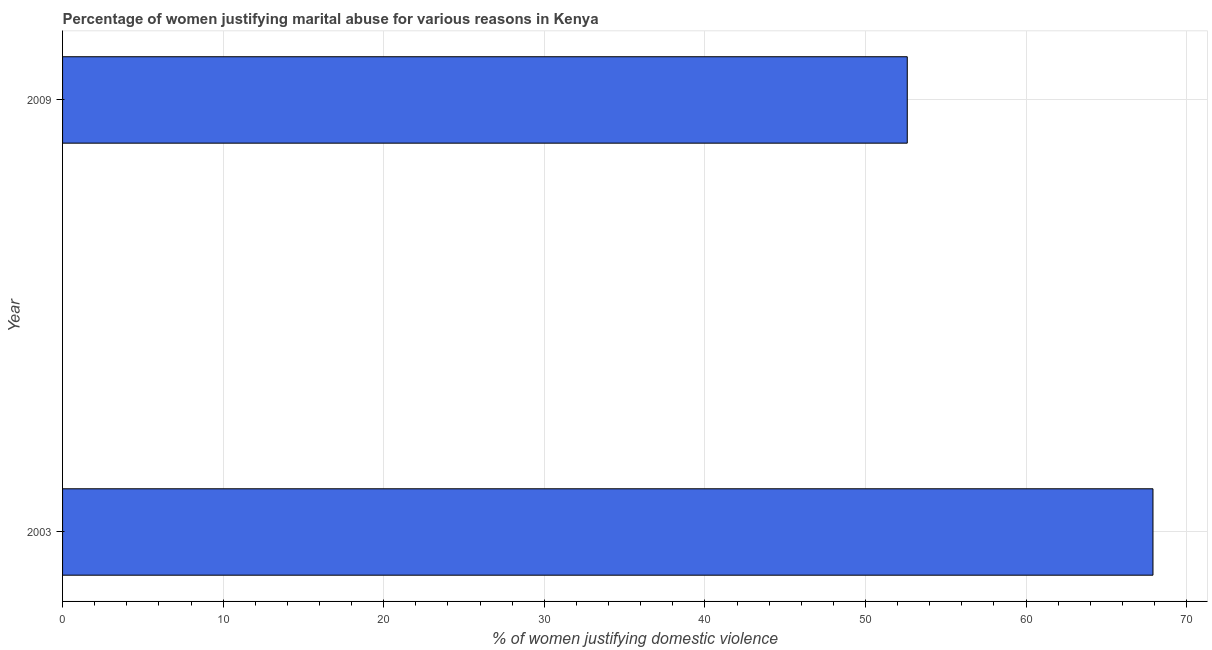Does the graph contain any zero values?
Keep it short and to the point. No. What is the title of the graph?
Give a very brief answer. Percentage of women justifying marital abuse for various reasons in Kenya. What is the label or title of the X-axis?
Give a very brief answer. % of women justifying domestic violence. What is the label or title of the Y-axis?
Provide a succinct answer. Year. What is the percentage of women justifying marital abuse in 2003?
Your response must be concise. 67.9. Across all years, what is the maximum percentage of women justifying marital abuse?
Your response must be concise. 67.9. Across all years, what is the minimum percentage of women justifying marital abuse?
Your answer should be very brief. 52.6. In which year was the percentage of women justifying marital abuse minimum?
Provide a succinct answer. 2009. What is the sum of the percentage of women justifying marital abuse?
Your answer should be compact. 120.5. What is the average percentage of women justifying marital abuse per year?
Provide a succinct answer. 60.25. What is the median percentage of women justifying marital abuse?
Offer a terse response. 60.25. In how many years, is the percentage of women justifying marital abuse greater than 16 %?
Provide a succinct answer. 2. Do a majority of the years between 2003 and 2009 (inclusive) have percentage of women justifying marital abuse greater than 2 %?
Offer a very short reply. Yes. What is the ratio of the percentage of women justifying marital abuse in 2003 to that in 2009?
Your response must be concise. 1.29. In how many years, is the percentage of women justifying marital abuse greater than the average percentage of women justifying marital abuse taken over all years?
Provide a short and direct response. 1. How many bars are there?
Your response must be concise. 2. Are all the bars in the graph horizontal?
Give a very brief answer. Yes. What is the % of women justifying domestic violence in 2003?
Offer a very short reply. 67.9. What is the % of women justifying domestic violence in 2009?
Your answer should be very brief. 52.6. What is the difference between the % of women justifying domestic violence in 2003 and 2009?
Ensure brevity in your answer.  15.3. What is the ratio of the % of women justifying domestic violence in 2003 to that in 2009?
Make the answer very short. 1.29. 